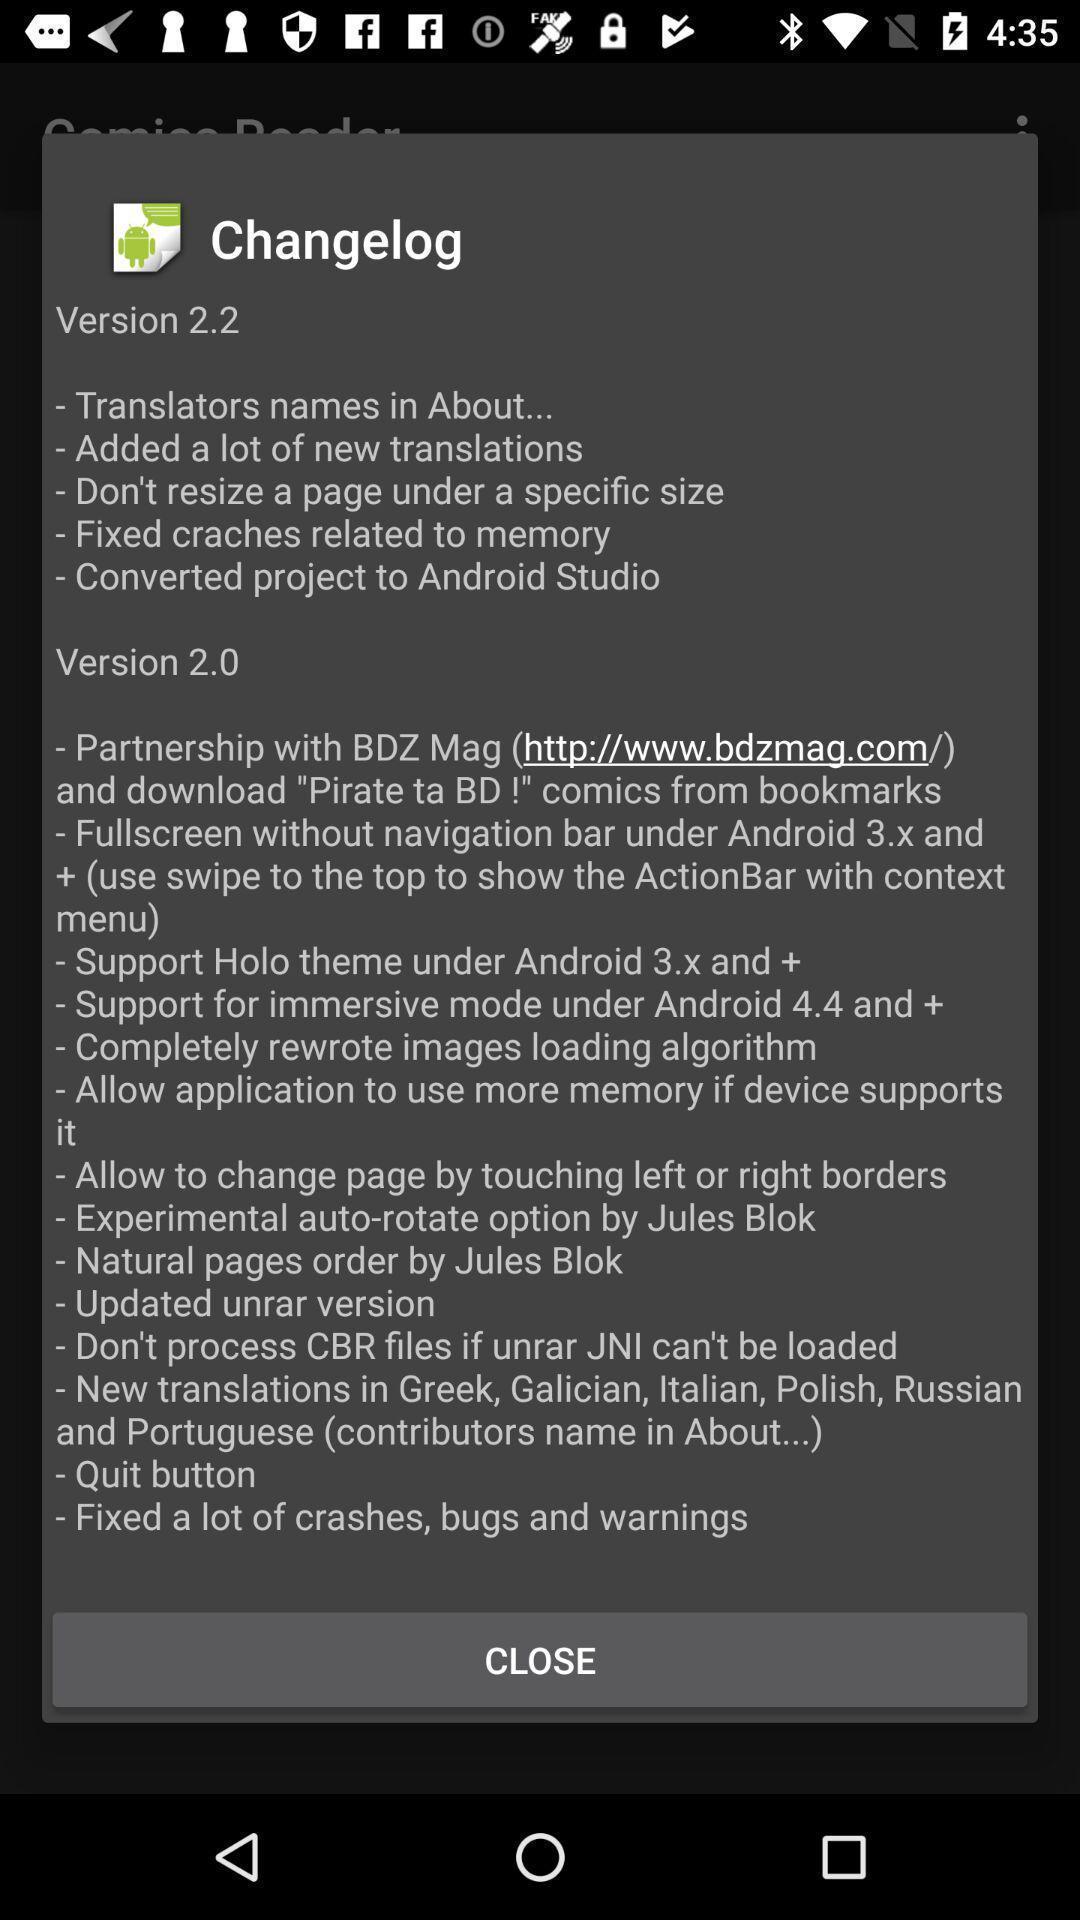Explain the elements present in this screenshot. Pop-up page displaying information about the application. 